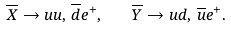<formula> <loc_0><loc_0><loc_500><loc_500>\overline { X } \rightarrow u u , \, \overline { d } e ^ { + } , \quad \overline { Y } \rightarrow u d , \, \overline { u } e ^ { + } .</formula> 